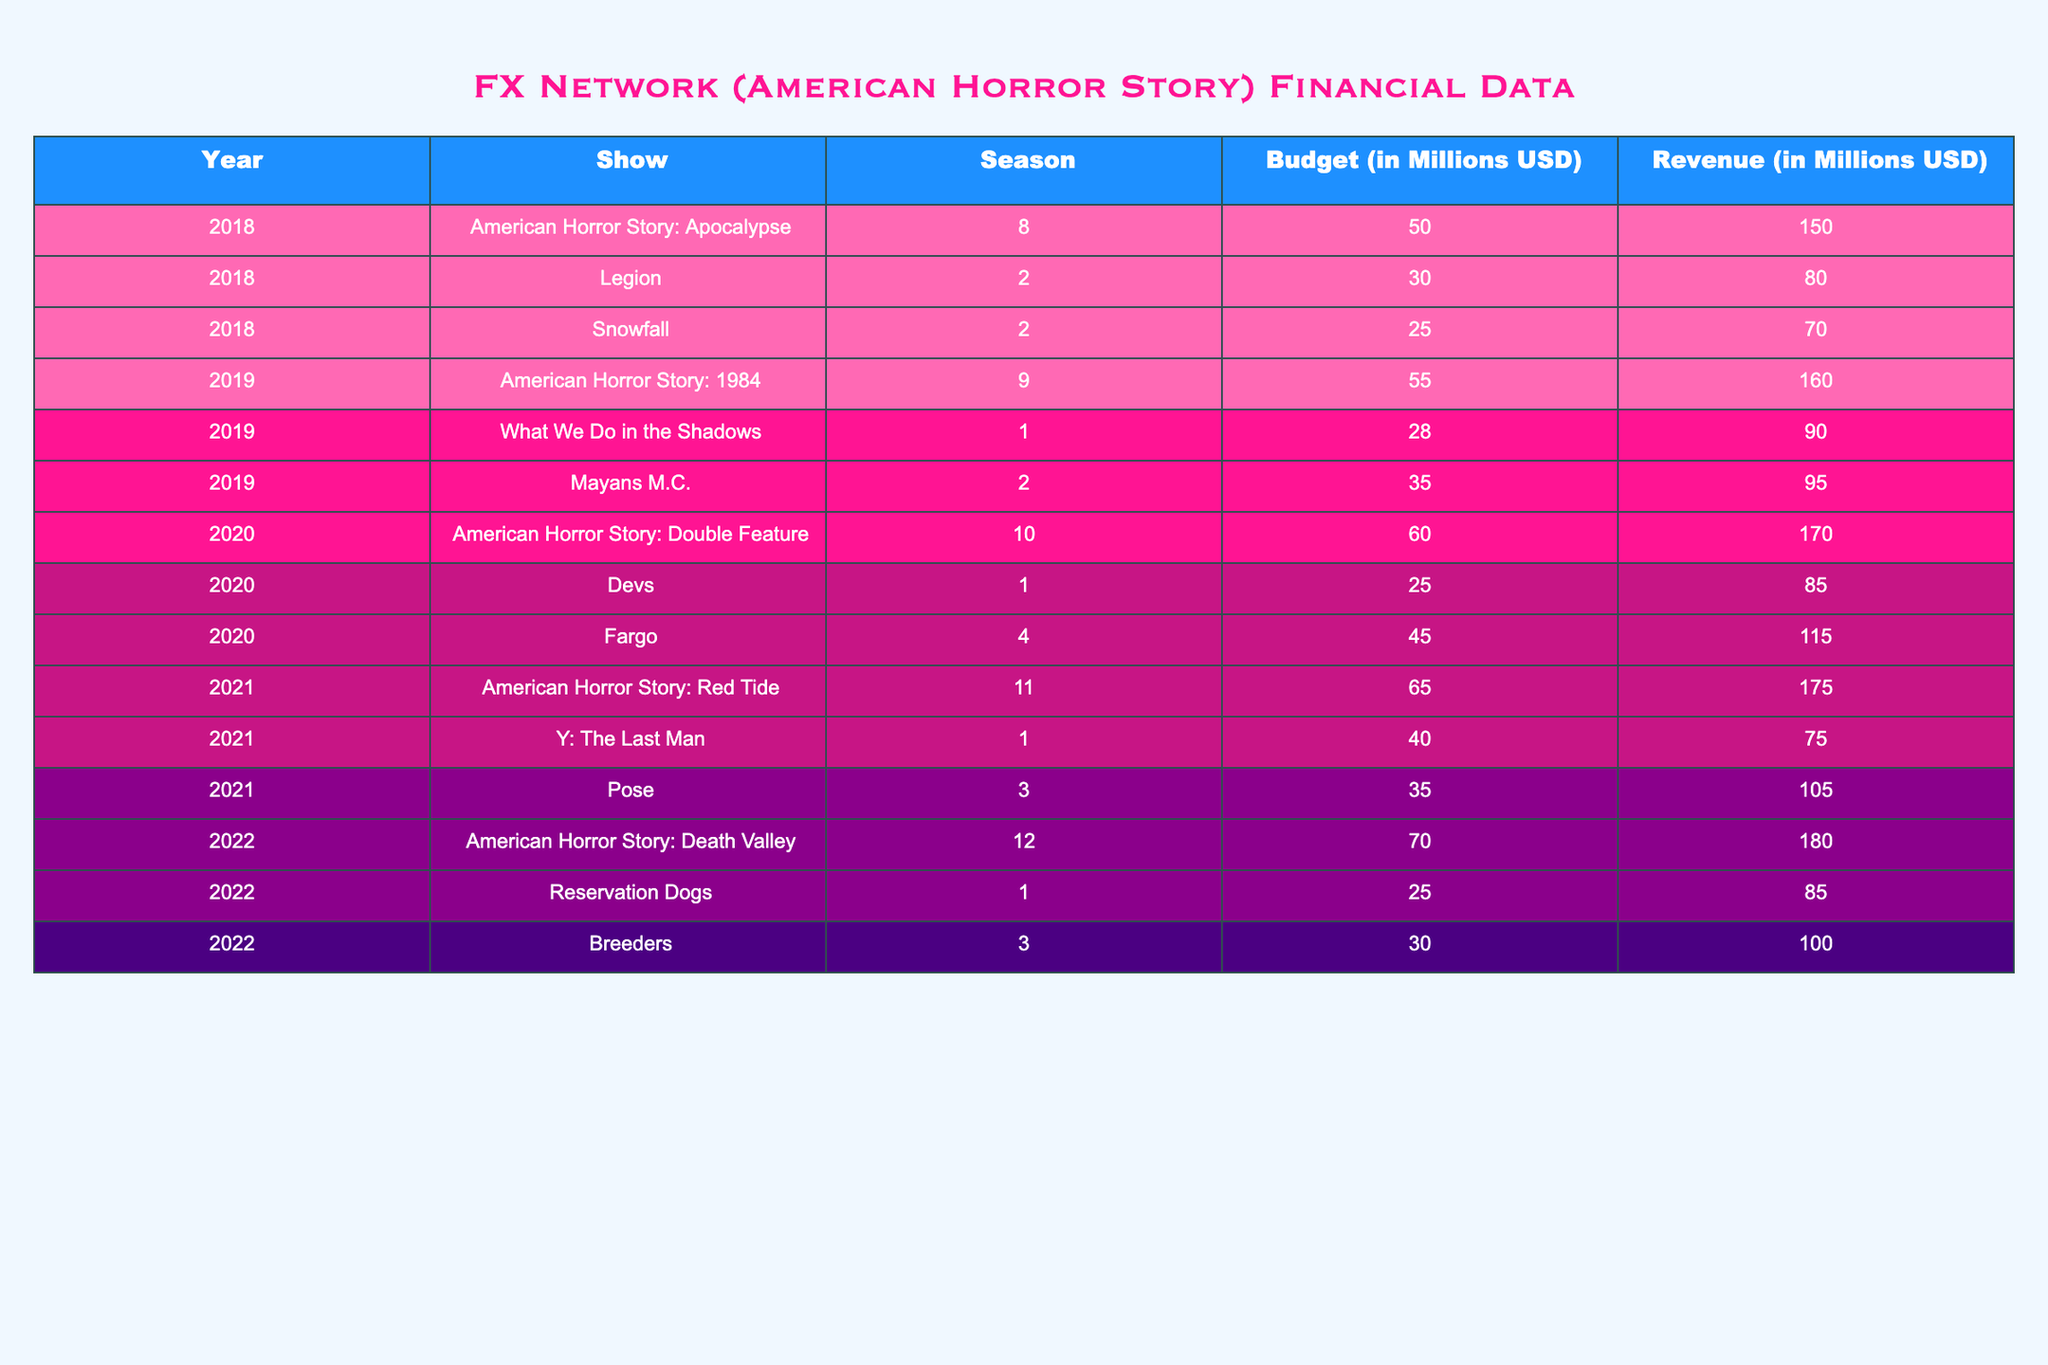What was the revenue for American Horror Story: Death Valley in 2022? Referring to the table, the row corresponding to American Horror Story: Death Valley under the year 2022 indicates a revenue of 180 million USD.
Answer: 180 million USD What is the total budget for all seasons of American Horror Story from 2018 to 2022? To find the total budget, we sum the budgets: 50 + 55 + 60 + 65 + 70 = 300 million USD.
Answer: 300 million USD Did the show Legion generate more revenue than its budget in 2018? For the show Legion in 2018, the budget was 30 million USD and the revenue was 80 million USD, confirming that it generated more revenue than its budget.
Answer: Yes Which season had the highest budget in 2021? Reviewing the table for 2021, American Horror Story: Red Tide had a budget of 65 million USD, which is higher compared to Y: The Last Man (40 million) and Pose (35 million).
Answer: American Horror Story: Red Tide What is the average revenue for all shows in 2019? To calculate the average, sum the revenues: 160 (AHS: 1984) + 90 (What We Do in the Shadows) + 95 (Mayans M.C.) = 345 million USD. Then divide by the number of shows (3): 345 / 3 = 115 million USD.
Answer: 115 million USD Was the revenue for Fargo in 2020 greater than that of Legion in 2018? The revenue for Fargo in 2020 was 115 million USD, while the revenue for Legion in 2018 was 80 million USD. Comparing the two shows reveals that Fargo's revenue was indeed greater.
Answer: Yes What show had the lowest revenue relative to its budget in 2020? Comparing the budget and revenue of each show in 2020, we calculate the revenue-to-budget ratios. Devs had a budget of 25 million and revenue of 85 million (ratio of 3.4), while Fargo had a ratio of 2.56, and American Horror Story: Double Feature had a ratio of 1.67. Therefore, American Horror Story: Double Feature had the lowest ratio, indicating less revenue relative to its budget.
Answer: American Horror Story: Double Feature How much revenue did the shows generate collectively in 2020? We sum the revenues of all shows for 2020: 170 (AHS: Double Feature) + 85 (Devs) + 115 (Fargo) = 370 million USD.
Answer: 370 million USD What percentage of the total budget for FX shows in 2022 was allocated to American Horror Story: Death Valley? The total budget for all shows in 2022 is 70 (AHS: Death Valley) + 25 (Reservation Dogs) + 30 (Breeders) = 125 million USD. To find the percentage for AHS: Death Valley, divide its budget (70) by the total budget (125) and multiply by 100: (70 / 125) * 100 = 56%.
Answer: 56% 